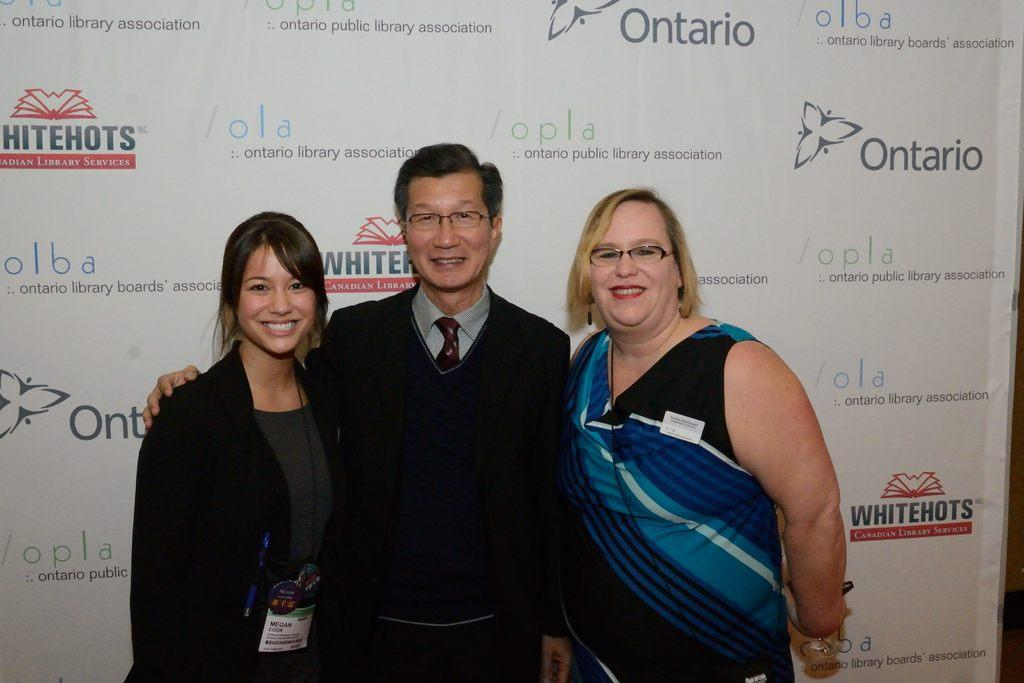<image>
Summarize the visual content of the image. Two women and a man pose in front of the wall with signs that says "Whitehots Canadian Library services". 